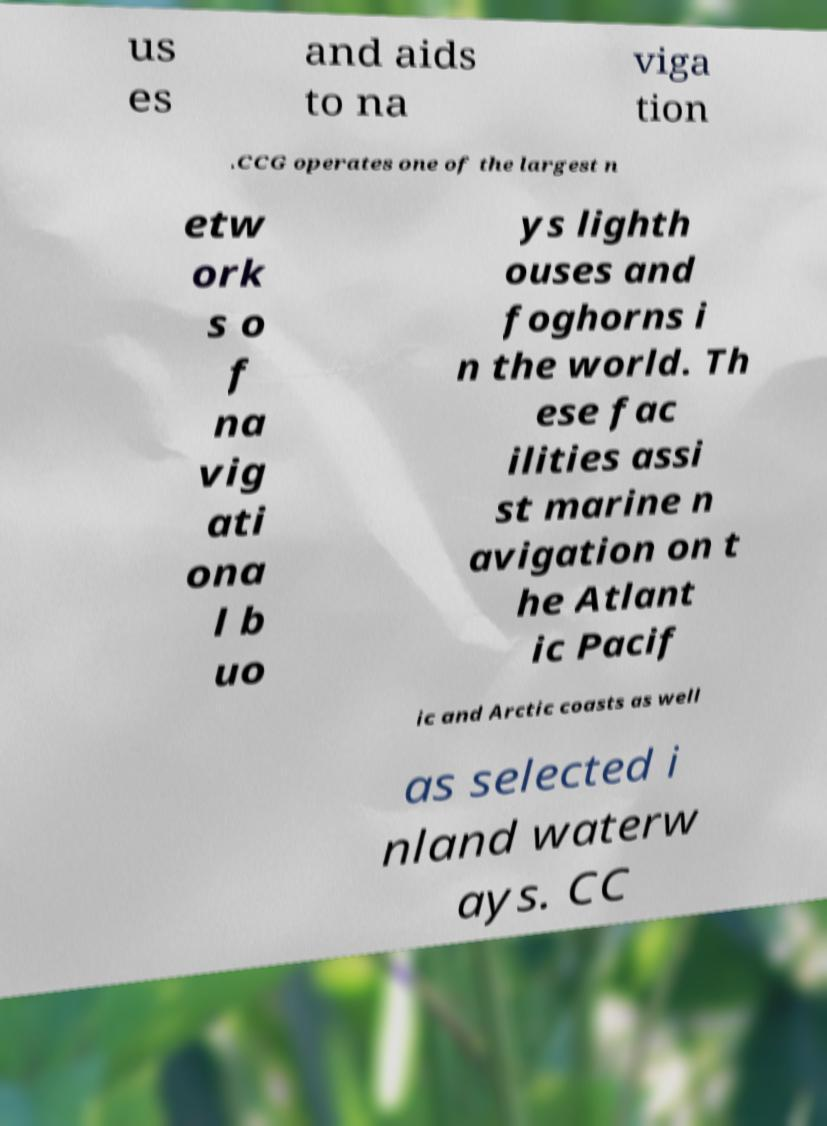Please read and relay the text visible in this image. What does it say? us es and aids to na viga tion .CCG operates one of the largest n etw ork s o f na vig ati ona l b uo ys lighth ouses and foghorns i n the world. Th ese fac ilities assi st marine n avigation on t he Atlant ic Pacif ic and Arctic coasts as well as selected i nland waterw ays. CC 